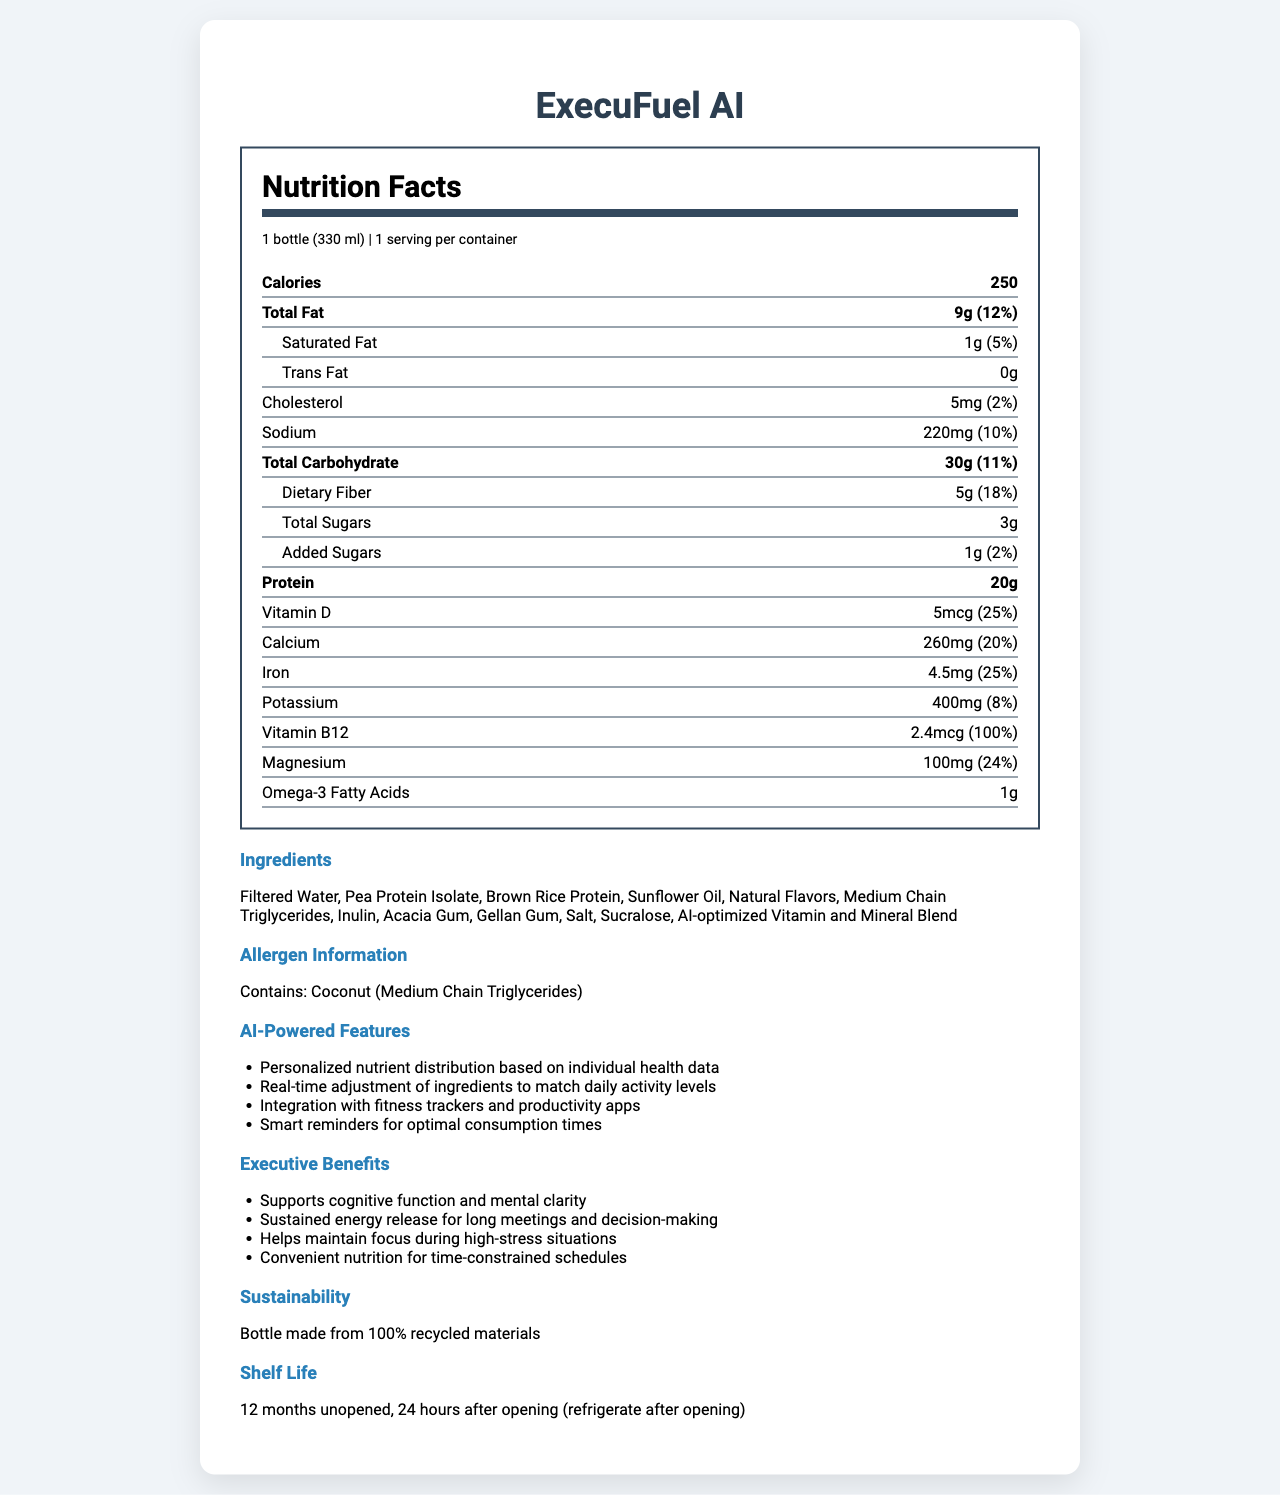what is the serving size for ExecuFuel AI? The serving size is clearly listed as "1 bottle (330 ml)" under the serving information section of the nutrition label.
Answer: 1 bottle (330 ml) how many grams of total fat are in the meal replacement shake? The amount of total fat is listed as "9g" in the nutrition facts section.
Answer: 9g what is the percentage of daily value for vitamin B12? The percentage of daily value for vitamin B12 is listed as "100%" in the nutrition facts section.
Answer: 100% what is the total carbohydrate content in this shake? The total carbohydrate content is clearly listed as "30g" in the nutrition facts section.
Answer: 30g how long does the product last once opened? The shelf life information states that the product lasts 24 hours after opening, and it should be refrigerated after opening.
Answer: 24 hours (refrigerate after opening) which AI-powered feature does ExecuFuel AI NOT have? A. Personalized nutrient distribution B. Real-time adjustment of ingredients C. Integration with productivity apps D. Voice assistance integration The document lists various AI-powered features but does not mention anything about voice assistance integration.
Answer: D what are the added sugars content in ExecuFuel AI? A. 0g B. 1g C. 3g D. 5g The added sugars content is listed as "1g" under the nutrition facts section, making option B correct.
Answer: B is ExecuFuel AI good for someone trying to increase their dietary fiber intake? ExecuFuel AI contains 5g of dietary fiber, which is 18% of the daily value, making it a good option for someone trying to increase their dietary fiber intake.
Answer: Yes does the product support cognitive function and mental clarity? Among the executive benefits listed, it is mentioned that the product supports cognitive function and mental clarity.
Answer: Yes describe the main features and benefits of ExecuFuel AI. The document describes a meal replacement shake named ExecuFuel AI specifically designed for executives. It includes features such as nutrient personalization based on health data, real-time adjustments, and app integration to support cognitive functions. The nutritional profile includes significant dietary fiber and protein, with a focus on sustaining energy and mental clarity. It highlights sustainability with a recycled bottle and provides detailed information on its ingredients and allergen content.
Answer: ExecuFuel AI is a meal replacement shake designed for busy executives, offering a balance of nutrients and AI-powered features. It provides 250 calories per serving with key nutrients to support energy levels and cognitive function. The shake includes personalized nutrient distribution, real-time ingredient adjustment, and integration with fitness trackers and productivity apps. It supports mental clarity, sustained energy, and focus during high-stress situations. The bottle is made from recycled materials, emphasizing sustainability. what is the origin of the natural flavors used in the shake? The document lists "Natural Flavors" among the ingredients but does not provide any details about their origin.
Answer: Not enough information 